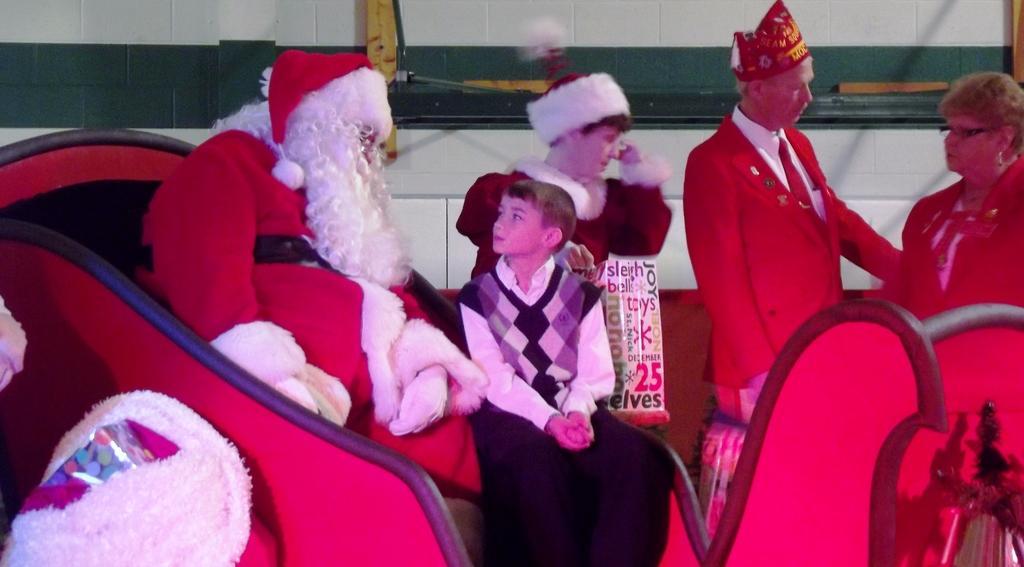Can you describe this image briefly? In this image, we can see few people. Here we can see a person is wearing a santa claus costume. Beside him a boy is sitting. Here we can see a poster. Background there is a wall. 